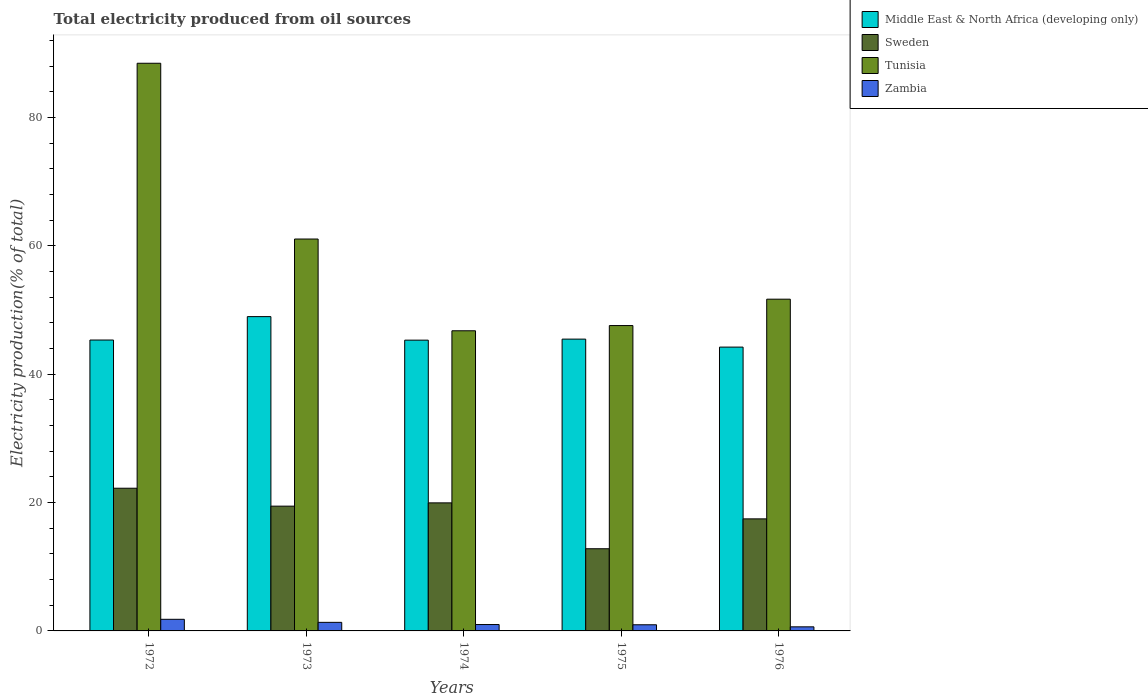How many bars are there on the 2nd tick from the left?
Your answer should be compact. 4. What is the label of the 3rd group of bars from the left?
Give a very brief answer. 1974. What is the total electricity produced in Middle East & North Africa (developing only) in 1975?
Make the answer very short. 45.47. Across all years, what is the maximum total electricity produced in Sweden?
Offer a very short reply. 22.24. Across all years, what is the minimum total electricity produced in Sweden?
Keep it short and to the point. 12.81. In which year was the total electricity produced in Tunisia maximum?
Your answer should be compact. 1972. In which year was the total electricity produced in Middle East & North Africa (developing only) minimum?
Keep it short and to the point. 1976. What is the total total electricity produced in Zambia in the graph?
Ensure brevity in your answer.  5.74. What is the difference between the total electricity produced in Tunisia in 1972 and that in 1973?
Your answer should be very brief. 27.39. What is the difference between the total electricity produced in Middle East & North Africa (developing only) in 1976 and the total electricity produced in Tunisia in 1972?
Provide a succinct answer. -44.23. What is the average total electricity produced in Zambia per year?
Provide a short and direct response. 1.15. In the year 1973, what is the difference between the total electricity produced in Middle East & North Africa (developing only) and total electricity produced in Sweden?
Offer a very short reply. 29.53. What is the ratio of the total electricity produced in Zambia in 1974 to that in 1976?
Your response must be concise. 1.56. What is the difference between the highest and the second highest total electricity produced in Zambia?
Provide a succinct answer. 0.48. What is the difference between the highest and the lowest total electricity produced in Sweden?
Your answer should be very brief. 9.43. Is the sum of the total electricity produced in Zambia in 1973 and 1974 greater than the maximum total electricity produced in Tunisia across all years?
Make the answer very short. No. Is it the case that in every year, the sum of the total electricity produced in Middle East & North Africa (developing only) and total electricity produced in Tunisia is greater than the sum of total electricity produced in Sweden and total electricity produced in Zambia?
Offer a terse response. Yes. What does the 3rd bar from the left in 1973 represents?
Give a very brief answer. Tunisia. What does the 3rd bar from the right in 1973 represents?
Make the answer very short. Sweden. How many bars are there?
Offer a terse response. 20. Are all the bars in the graph horizontal?
Your answer should be very brief. No. How many years are there in the graph?
Offer a very short reply. 5. Does the graph contain any zero values?
Ensure brevity in your answer.  No. How are the legend labels stacked?
Provide a short and direct response. Vertical. What is the title of the graph?
Offer a terse response. Total electricity produced from oil sources. What is the label or title of the Y-axis?
Make the answer very short. Electricity production(% of total). What is the Electricity production(% of total) in Middle East & North Africa (developing only) in 1972?
Make the answer very short. 45.33. What is the Electricity production(% of total) in Sweden in 1972?
Ensure brevity in your answer.  22.24. What is the Electricity production(% of total) in Tunisia in 1972?
Ensure brevity in your answer.  88.46. What is the Electricity production(% of total) in Zambia in 1972?
Your answer should be very brief. 1.81. What is the Electricity production(% of total) of Middle East & North Africa (developing only) in 1973?
Offer a terse response. 48.98. What is the Electricity production(% of total) in Sweden in 1973?
Provide a succinct answer. 19.44. What is the Electricity production(% of total) of Tunisia in 1973?
Make the answer very short. 61.07. What is the Electricity production(% of total) in Zambia in 1973?
Your response must be concise. 1.34. What is the Electricity production(% of total) of Middle East & North Africa (developing only) in 1974?
Make the answer very short. 45.31. What is the Electricity production(% of total) in Sweden in 1974?
Your response must be concise. 19.95. What is the Electricity production(% of total) of Tunisia in 1974?
Provide a succinct answer. 46.77. What is the Electricity production(% of total) in Zambia in 1974?
Keep it short and to the point. 0.99. What is the Electricity production(% of total) in Middle East & North Africa (developing only) in 1975?
Your response must be concise. 45.47. What is the Electricity production(% of total) of Sweden in 1975?
Your response must be concise. 12.81. What is the Electricity production(% of total) of Tunisia in 1975?
Your answer should be very brief. 47.59. What is the Electricity production(% of total) in Zambia in 1975?
Provide a succinct answer. 0.96. What is the Electricity production(% of total) in Middle East & North Africa (developing only) in 1976?
Your response must be concise. 44.23. What is the Electricity production(% of total) in Sweden in 1976?
Your answer should be very brief. 17.46. What is the Electricity production(% of total) in Tunisia in 1976?
Keep it short and to the point. 51.69. What is the Electricity production(% of total) of Zambia in 1976?
Offer a very short reply. 0.64. Across all years, what is the maximum Electricity production(% of total) in Middle East & North Africa (developing only)?
Offer a very short reply. 48.98. Across all years, what is the maximum Electricity production(% of total) of Sweden?
Make the answer very short. 22.24. Across all years, what is the maximum Electricity production(% of total) of Tunisia?
Provide a short and direct response. 88.46. Across all years, what is the maximum Electricity production(% of total) in Zambia?
Your response must be concise. 1.81. Across all years, what is the minimum Electricity production(% of total) in Middle East & North Africa (developing only)?
Make the answer very short. 44.23. Across all years, what is the minimum Electricity production(% of total) of Sweden?
Your answer should be very brief. 12.81. Across all years, what is the minimum Electricity production(% of total) of Tunisia?
Give a very brief answer. 46.77. Across all years, what is the minimum Electricity production(% of total) of Zambia?
Keep it short and to the point. 0.64. What is the total Electricity production(% of total) in Middle East & North Africa (developing only) in the graph?
Your response must be concise. 229.31. What is the total Electricity production(% of total) in Sweden in the graph?
Make the answer very short. 91.9. What is the total Electricity production(% of total) of Tunisia in the graph?
Provide a succinct answer. 295.58. What is the total Electricity production(% of total) of Zambia in the graph?
Offer a terse response. 5.74. What is the difference between the Electricity production(% of total) in Middle East & North Africa (developing only) in 1972 and that in 1973?
Make the answer very short. -3.65. What is the difference between the Electricity production(% of total) in Sweden in 1972 and that in 1973?
Offer a terse response. 2.79. What is the difference between the Electricity production(% of total) of Tunisia in 1972 and that in 1973?
Your response must be concise. 27.39. What is the difference between the Electricity production(% of total) in Zambia in 1972 and that in 1973?
Provide a succinct answer. 0.48. What is the difference between the Electricity production(% of total) of Middle East & North Africa (developing only) in 1972 and that in 1974?
Keep it short and to the point. 0.02. What is the difference between the Electricity production(% of total) in Sweden in 1972 and that in 1974?
Make the answer very short. 2.28. What is the difference between the Electricity production(% of total) of Tunisia in 1972 and that in 1974?
Give a very brief answer. 41.69. What is the difference between the Electricity production(% of total) of Zambia in 1972 and that in 1974?
Give a very brief answer. 0.82. What is the difference between the Electricity production(% of total) in Middle East & North Africa (developing only) in 1972 and that in 1975?
Give a very brief answer. -0.14. What is the difference between the Electricity production(% of total) in Sweden in 1972 and that in 1975?
Make the answer very short. 9.43. What is the difference between the Electricity production(% of total) of Tunisia in 1972 and that in 1975?
Your answer should be compact. 40.87. What is the difference between the Electricity production(% of total) of Zambia in 1972 and that in 1975?
Offer a very short reply. 0.85. What is the difference between the Electricity production(% of total) of Middle East & North Africa (developing only) in 1972 and that in 1976?
Your answer should be compact. 1.1. What is the difference between the Electricity production(% of total) in Sweden in 1972 and that in 1976?
Ensure brevity in your answer.  4.77. What is the difference between the Electricity production(% of total) of Tunisia in 1972 and that in 1976?
Give a very brief answer. 36.76. What is the difference between the Electricity production(% of total) in Zambia in 1972 and that in 1976?
Make the answer very short. 1.18. What is the difference between the Electricity production(% of total) in Middle East & North Africa (developing only) in 1973 and that in 1974?
Your response must be concise. 3.67. What is the difference between the Electricity production(% of total) of Sweden in 1973 and that in 1974?
Provide a succinct answer. -0.51. What is the difference between the Electricity production(% of total) in Tunisia in 1973 and that in 1974?
Offer a terse response. 14.3. What is the difference between the Electricity production(% of total) of Zambia in 1973 and that in 1974?
Your answer should be compact. 0.34. What is the difference between the Electricity production(% of total) of Middle East & North Africa (developing only) in 1973 and that in 1975?
Your answer should be very brief. 3.51. What is the difference between the Electricity production(% of total) of Sweden in 1973 and that in 1975?
Your response must be concise. 6.64. What is the difference between the Electricity production(% of total) in Tunisia in 1973 and that in 1975?
Make the answer very short. 13.48. What is the difference between the Electricity production(% of total) in Zambia in 1973 and that in 1975?
Provide a short and direct response. 0.38. What is the difference between the Electricity production(% of total) in Middle East & North Africa (developing only) in 1973 and that in 1976?
Your response must be concise. 4.75. What is the difference between the Electricity production(% of total) of Sweden in 1973 and that in 1976?
Provide a succinct answer. 1.98. What is the difference between the Electricity production(% of total) in Tunisia in 1973 and that in 1976?
Keep it short and to the point. 9.37. What is the difference between the Electricity production(% of total) in Zambia in 1973 and that in 1976?
Keep it short and to the point. 0.7. What is the difference between the Electricity production(% of total) in Middle East & North Africa (developing only) in 1974 and that in 1975?
Ensure brevity in your answer.  -0.16. What is the difference between the Electricity production(% of total) of Sweden in 1974 and that in 1975?
Offer a very short reply. 7.15. What is the difference between the Electricity production(% of total) of Tunisia in 1974 and that in 1975?
Your answer should be compact. -0.81. What is the difference between the Electricity production(% of total) of Zambia in 1974 and that in 1975?
Your answer should be very brief. 0.04. What is the difference between the Electricity production(% of total) in Middle East & North Africa (developing only) in 1974 and that in 1976?
Provide a succinct answer. 1.08. What is the difference between the Electricity production(% of total) of Sweden in 1974 and that in 1976?
Offer a very short reply. 2.49. What is the difference between the Electricity production(% of total) in Tunisia in 1974 and that in 1976?
Your answer should be very brief. -4.92. What is the difference between the Electricity production(% of total) of Zambia in 1974 and that in 1976?
Provide a short and direct response. 0.36. What is the difference between the Electricity production(% of total) in Middle East & North Africa (developing only) in 1975 and that in 1976?
Your response must be concise. 1.25. What is the difference between the Electricity production(% of total) of Sweden in 1975 and that in 1976?
Offer a terse response. -4.66. What is the difference between the Electricity production(% of total) of Tunisia in 1975 and that in 1976?
Make the answer very short. -4.11. What is the difference between the Electricity production(% of total) of Zambia in 1975 and that in 1976?
Your response must be concise. 0.32. What is the difference between the Electricity production(% of total) in Middle East & North Africa (developing only) in 1972 and the Electricity production(% of total) in Sweden in 1973?
Provide a short and direct response. 25.89. What is the difference between the Electricity production(% of total) in Middle East & North Africa (developing only) in 1972 and the Electricity production(% of total) in Tunisia in 1973?
Your answer should be compact. -15.74. What is the difference between the Electricity production(% of total) in Middle East & North Africa (developing only) in 1972 and the Electricity production(% of total) in Zambia in 1973?
Offer a very short reply. 43.99. What is the difference between the Electricity production(% of total) in Sweden in 1972 and the Electricity production(% of total) in Tunisia in 1973?
Your answer should be very brief. -38.83. What is the difference between the Electricity production(% of total) of Sweden in 1972 and the Electricity production(% of total) of Zambia in 1973?
Offer a terse response. 20.9. What is the difference between the Electricity production(% of total) of Tunisia in 1972 and the Electricity production(% of total) of Zambia in 1973?
Offer a terse response. 87.12. What is the difference between the Electricity production(% of total) in Middle East & North Africa (developing only) in 1972 and the Electricity production(% of total) in Sweden in 1974?
Your response must be concise. 25.38. What is the difference between the Electricity production(% of total) in Middle East & North Africa (developing only) in 1972 and the Electricity production(% of total) in Tunisia in 1974?
Give a very brief answer. -1.44. What is the difference between the Electricity production(% of total) in Middle East & North Africa (developing only) in 1972 and the Electricity production(% of total) in Zambia in 1974?
Your answer should be very brief. 44.34. What is the difference between the Electricity production(% of total) of Sweden in 1972 and the Electricity production(% of total) of Tunisia in 1974?
Provide a short and direct response. -24.54. What is the difference between the Electricity production(% of total) in Sweden in 1972 and the Electricity production(% of total) in Zambia in 1974?
Your response must be concise. 21.24. What is the difference between the Electricity production(% of total) in Tunisia in 1972 and the Electricity production(% of total) in Zambia in 1974?
Provide a succinct answer. 87.46. What is the difference between the Electricity production(% of total) in Middle East & North Africa (developing only) in 1972 and the Electricity production(% of total) in Sweden in 1975?
Provide a succinct answer. 32.52. What is the difference between the Electricity production(% of total) in Middle East & North Africa (developing only) in 1972 and the Electricity production(% of total) in Tunisia in 1975?
Keep it short and to the point. -2.26. What is the difference between the Electricity production(% of total) of Middle East & North Africa (developing only) in 1972 and the Electricity production(% of total) of Zambia in 1975?
Ensure brevity in your answer.  44.37. What is the difference between the Electricity production(% of total) in Sweden in 1972 and the Electricity production(% of total) in Tunisia in 1975?
Your answer should be very brief. -25.35. What is the difference between the Electricity production(% of total) of Sweden in 1972 and the Electricity production(% of total) of Zambia in 1975?
Your answer should be compact. 21.28. What is the difference between the Electricity production(% of total) in Tunisia in 1972 and the Electricity production(% of total) in Zambia in 1975?
Keep it short and to the point. 87.5. What is the difference between the Electricity production(% of total) of Middle East & North Africa (developing only) in 1972 and the Electricity production(% of total) of Sweden in 1976?
Make the answer very short. 27.87. What is the difference between the Electricity production(% of total) of Middle East & North Africa (developing only) in 1972 and the Electricity production(% of total) of Tunisia in 1976?
Your answer should be compact. -6.36. What is the difference between the Electricity production(% of total) in Middle East & North Africa (developing only) in 1972 and the Electricity production(% of total) in Zambia in 1976?
Keep it short and to the point. 44.69. What is the difference between the Electricity production(% of total) of Sweden in 1972 and the Electricity production(% of total) of Tunisia in 1976?
Ensure brevity in your answer.  -29.46. What is the difference between the Electricity production(% of total) in Sweden in 1972 and the Electricity production(% of total) in Zambia in 1976?
Ensure brevity in your answer.  21.6. What is the difference between the Electricity production(% of total) in Tunisia in 1972 and the Electricity production(% of total) in Zambia in 1976?
Make the answer very short. 87.82. What is the difference between the Electricity production(% of total) in Middle East & North Africa (developing only) in 1973 and the Electricity production(% of total) in Sweden in 1974?
Make the answer very short. 29.02. What is the difference between the Electricity production(% of total) of Middle East & North Africa (developing only) in 1973 and the Electricity production(% of total) of Tunisia in 1974?
Your answer should be compact. 2.21. What is the difference between the Electricity production(% of total) in Middle East & North Africa (developing only) in 1973 and the Electricity production(% of total) in Zambia in 1974?
Provide a succinct answer. 47.98. What is the difference between the Electricity production(% of total) in Sweden in 1973 and the Electricity production(% of total) in Tunisia in 1974?
Provide a succinct answer. -27.33. What is the difference between the Electricity production(% of total) of Sweden in 1973 and the Electricity production(% of total) of Zambia in 1974?
Keep it short and to the point. 18.45. What is the difference between the Electricity production(% of total) of Tunisia in 1973 and the Electricity production(% of total) of Zambia in 1974?
Offer a terse response. 60.07. What is the difference between the Electricity production(% of total) of Middle East & North Africa (developing only) in 1973 and the Electricity production(% of total) of Sweden in 1975?
Ensure brevity in your answer.  36.17. What is the difference between the Electricity production(% of total) in Middle East & North Africa (developing only) in 1973 and the Electricity production(% of total) in Tunisia in 1975?
Your answer should be compact. 1.39. What is the difference between the Electricity production(% of total) of Middle East & North Africa (developing only) in 1973 and the Electricity production(% of total) of Zambia in 1975?
Offer a terse response. 48.02. What is the difference between the Electricity production(% of total) in Sweden in 1973 and the Electricity production(% of total) in Tunisia in 1975?
Ensure brevity in your answer.  -28.14. What is the difference between the Electricity production(% of total) of Sweden in 1973 and the Electricity production(% of total) of Zambia in 1975?
Provide a succinct answer. 18.48. What is the difference between the Electricity production(% of total) in Tunisia in 1973 and the Electricity production(% of total) in Zambia in 1975?
Ensure brevity in your answer.  60.11. What is the difference between the Electricity production(% of total) in Middle East & North Africa (developing only) in 1973 and the Electricity production(% of total) in Sweden in 1976?
Provide a succinct answer. 31.52. What is the difference between the Electricity production(% of total) in Middle East & North Africa (developing only) in 1973 and the Electricity production(% of total) in Tunisia in 1976?
Ensure brevity in your answer.  -2.72. What is the difference between the Electricity production(% of total) of Middle East & North Africa (developing only) in 1973 and the Electricity production(% of total) of Zambia in 1976?
Your answer should be compact. 48.34. What is the difference between the Electricity production(% of total) in Sweden in 1973 and the Electricity production(% of total) in Tunisia in 1976?
Offer a very short reply. -32.25. What is the difference between the Electricity production(% of total) in Sweden in 1973 and the Electricity production(% of total) in Zambia in 1976?
Your answer should be very brief. 18.81. What is the difference between the Electricity production(% of total) of Tunisia in 1973 and the Electricity production(% of total) of Zambia in 1976?
Give a very brief answer. 60.43. What is the difference between the Electricity production(% of total) in Middle East & North Africa (developing only) in 1974 and the Electricity production(% of total) in Sweden in 1975?
Offer a terse response. 32.5. What is the difference between the Electricity production(% of total) of Middle East & North Africa (developing only) in 1974 and the Electricity production(% of total) of Tunisia in 1975?
Your answer should be compact. -2.28. What is the difference between the Electricity production(% of total) in Middle East & North Africa (developing only) in 1974 and the Electricity production(% of total) in Zambia in 1975?
Give a very brief answer. 44.35. What is the difference between the Electricity production(% of total) of Sweden in 1974 and the Electricity production(% of total) of Tunisia in 1975?
Your answer should be compact. -27.63. What is the difference between the Electricity production(% of total) of Sweden in 1974 and the Electricity production(% of total) of Zambia in 1975?
Offer a terse response. 18.99. What is the difference between the Electricity production(% of total) of Tunisia in 1974 and the Electricity production(% of total) of Zambia in 1975?
Ensure brevity in your answer.  45.81. What is the difference between the Electricity production(% of total) of Middle East & North Africa (developing only) in 1974 and the Electricity production(% of total) of Sweden in 1976?
Offer a terse response. 27.85. What is the difference between the Electricity production(% of total) of Middle East & North Africa (developing only) in 1974 and the Electricity production(% of total) of Tunisia in 1976?
Give a very brief answer. -6.38. What is the difference between the Electricity production(% of total) in Middle East & North Africa (developing only) in 1974 and the Electricity production(% of total) in Zambia in 1976?
Keep it short and to the point. 44.67. What is the difference between the Electricity production(% of total) of Sweden in 1974 and the Electricity production(% of total) of Tunisia in 1976?
Make the answer very short. -31.74. What is the difference between the Electricity production(% of total) in Sweden in 1974 and the Electricity production(% of total) in Zambia in 1976?
Offer a very short reply. 19.32. What is the difference between the Electricity production(% of total) in Tunisia in 1974 and the Electricity production(% of total) in Zambia in 1976?
Keep it short and to the point. 46.14. What is the difference between the Electricity production(% of total) of Middle East & North Africa (developing only) in 1975 and the Electricity production(% of total) of Sweden in 1976?
Your answer should be very brief. 28.01. What is the difference between the Electricity production(% of total) in Middle East & North Africa (developing only) in 1975 and the Electricity production(% of total) in Tunisia in 1976?
Your response must be concise. -6.22. What is the difference between the Electricity production(% of total) of Middle East & North Africa (developing only) in 1975 and the Electricity production(% of total) of Zambia in 1976?
Provide a short and direct response. 44.84. What is the difference between the Electricity production(% of total) of Sweden in 1975 and the Electricity production(% of total) of Tunisia in 1976?
Provide a short and direct response. -38.89. What is the difference between the Electricity production(% of total) in Sweden in 1975 and the Electricity production(% of total) in Zambia in 1976?
Your answer should be very brief. 12.17. What is the difference between the Electricity production(% of total) in Tunisia in 1975 and the Electricity production(% of total) in Zambia in 1976?
Offer a very short reply. 46.95. What is the average Electricity production(% of total) of Middle East & North Africa (developing only) per year?
Make the answer very short. 45.86. What is the average Electricity production(% of total) in Sweden per year?
Keep it short and to the point. 18.38. What is the average Electricity production(% of total) in Tunisia per year?
Your response must be concise. 59.12. What is the average Electricity production(% of total) in Zambia per year?
Your answer should be very brief. 1.15. In the year 1972, what is the difference between the Electricity production(% of total) in Middle East & North Africa (developing only) and Electricity production(% of total) in Sweden?
Make the answer very short. 23.09. In the year 1972, what is the difference between the Electricity production(% of total) of Middle East & North Africa (developing only) and Electricity production(% of total) of Tunisia?
Provide a short and direct response. -43.13. In the year 1972, what is the difference between the Electricity production(% of total) in Middle East & North Africa (developing only) and Electricity production(% of total) in Zambia?
Your answer should be very brief. 43.52. In the year 1972, what is the difference between the Electricity production(% of total) in Sweden and Electricity production(% of total) in Tunisia?
Provide a succinct answer. -66.22. In the year 1972, what is the difference between the Electricity production(% of total) in Sweden and Electricity production(% of total) in Zambia?
Ensure brevity in your answer.  20.43. In the year 1972, what is the difference between the Electricity production(% of total) in Tunisia and Electricity production(% of total) in Zambia?
Provide a short and direct response. 86.65. In the year 1973, what is the difference between the Electricity production(% of total) of Middle East & North Africa (developing only) and Electricity production(% of total) of Sweden?
Your answer should be compact. 29.53. In the year 1973, what is the difference between the Electricity production(% of total) in Middle East & North Africa (developing only) and Electricity production(% of total) in Tunisia?
Make the answer very short. -12.09. In the year 1973, what is the difference between the Electricity production(% of total) in Middle East & North Africa (developing only) and Electricity production(% of total) in Zambia?
Offer a terse response. 47.64. In the year 1973, what is the difference between the Electricity production(% of total) in Sweden and Electricity production(% of total) in Tunisia?
Ensure brevity in your answer.  -41.63. In the year 1973, what is the difference between the Electricity production(% of total) of Sweden and Electricity production(% of total) of Zambia?
Give a very brief answer. 18.11. In the year 1973, what is the difference between the Electricity production(% of total) in Tunisia and Electricity production(% of total) in Zambia?
Make the answer very short. 59.73. In the year 1974, what is the difference between the Electricity production(% of total) in Middle East & North Africa (developing only) and Electricity production(% of total) in Sweden?
Provide a short and direct response. 25.36. In the year 1974, what is the difference between the Electricity production(% of total) of Middle East & North Africa (developing only) and Electricity production(% of total) of Tunisia?
Provide a succinct answer. -1.46. In the year 1974, what is the difference between the Electricity production(% of total) of Middle East & North Africa (developing only) and Electricity production(% of total) of Zambia?
Ensure brevity in your answer.  44.32. In the year 1974, what is the difference between the Electricity production(% of total) of Sweden and Electricity production(% of total) of Tunisia?
Give a very brief answer. -26.82. In the year 1974, what is the difference between the Electricity production(% of total) of Sweden and Electricity production(% of total) of Zambia?
Give a very brief answer. 18.96. In the year 1974, what is the difference between the Electricity production(% of total) of Tunisia and Electricity production(% of total) of Zambia?
Keep it short and to the point. 45.78. In the year 1975, what is the difference between the Electricity production(% of total) of Middle East & North Africa (developing only) and Electricity production(% of total) of Sweden?
Offer a very short reply. 32.67. In the year 1975, what is the difference between the Electricity production(% of total) of Middle East & North Africa (developing only) and Electricity production(% of total) of Tunisia?
Your response must be concise. -2.11. In the year 1975, what is the difference between the Electricity production(% of total) in Middle East & North Africa (developing only) and Electricity production(% of total) in Zambia?
Your answer should be compact. 44.51. In the year 1975, what is the difference between the Electricity production(% of total) of Sweden and Electricity production(% of total) of Tunisia?
Your answer should be compact. -34.78. In the year 1975, what is the difference between the Electricity production(% of total) in Sweden and Electricity production(% of total) in Zambia?
Offer a very short reply. 11.85. In the year 1975, what is the difference between the Electricity production(% of total) in Tunisia and Electricity production(% of total) in Zambia?
Your answer should be compact. 46.63. In the year 1976, what is the difference between the Electricity production(% of total) of Middle East & North Africa (developing only) and Electricity production(% of total) of Sweden?
Provide a short and direct response. 26.76. In the year 1976, what is the difference between the Electricity production(% of total) in Middle East & North Africa (developing only) and Electricity production(% of total) in Tunisia?
Provide a short and direct response. -7.47. In the year 1976, what is the difference between the Electricity production(% of total) of Middle East & North Africa (developing only) and Electricity production(% of total) of Zambia?
Make the answer very short. 43.59. In the year 1976, what is the difference between the Electricity production(% of total) of Sweden and Electricity production(% of total) of Tunisia?
Your response must be concise. -34.23. In the year 1976, what is the difference between the Electricity production(% of total) of Sweden and Electricity production(% of total) of Zambia?
Your answer should be very brief. 16.83. In the year 1976, what is the difference between the Electricity production(% of total) of Tunisia and Electricity production(% of total) of Zambia?
Offer a very short reply. 51.06. What is the ratio of the Electricity production(% of total) of Middle East & North Africa (developing only) in 1972 to that in 1973?
Your answer should be very brief. 0.93. What is the ratio of the Electricity production(% of total) in Sweden in 1972 to that in 1973?
Provide a succinct answer. 1.14. What is the ratio of the Electricity production(% of total) of Tunisia in 1972 to that in 1973?
Offer a terse response. 1.45. What is the ratio of the Electricity production(% of total) of Zambia in 1972 to that in 1973?
Your answer should be very brief. 1.36. What is the ratio of the Electricity production(% of total) in Middle East & North Africa (developing only) in 1972 to that in 1974?
Keep it short and to the point. 1. What is the ratio of the Electricity production(% of total) of Sweden in 1972 to that in 1974?
Keep it short and to the point. 1.11. What is the ratio of the Electricity production(% of total) in Tunisia in 1972 to that in 1974?
Provide a succinct answer. 1.89. What is the ratio of the Electricity production(% of total) in Zambia in 1972 to that in 1974?
Offer a terse response. 1.82. What is the ratio of the Electricity production(% of total) in Sweden in 1972 to that in 1975?
Your answer should be compact. 1.74. What is the ratio of the Electricity production(% of total) in Tunisia in 1972 to that in 1975?
Your answer should be compact. 1.86. What is the ratio of the Electricity production(% of total) in Zambia in 1972 to that in 1975?
Offer a terse response. 1.89. What is the ratio of the Electricity production(% of total) of Middle East & North Africa (developing only) in 1972 to that in 1976?
Offer a terse response. 1.02. What is the ratio of the Electricity production(% of total) of Sweden in 1972 to that in 1976?
Give a very brief answer. 1.27. What is the ratio of the Electricity production(% of total) in Tunisia in 1972 to that in 1976?
Keep it short and to the point. 1.71. What is the ratio of the Electricity production(% of total) in Zambia in 1972 to that in 1976?
Provide a succinct answer. 2.85. What is the ratio of the Electricity production(% of total) in Middle East & North Africa (developing only) in 1973 to that in 1974?
Ensure brevity in your answer.  1.08. What is the ratio of the Electricity production(% of total) in Sweden in 1973 to that in 1974?
Provide a short and direct response. 0.97. What is the ratio of the Electricity production(% of total) in Tunisia in 1973 to that in 1974?
Keep it short and to the point. 1.31. What is the ratio of the Electricity production(% of total) of Zambia in 1973 to that in 1974?
Ensure brevity in your answer.  1.34. What is the ratio of the Electricity production(% of total) of Middle East & North Africa (developing only) in 1973 to that in 1975?
Provide a short and direct response. 1.08. What is the ratio of the Electricity production(% of total) of Sweden in 1973 to that in 1975?
Give a very brief answer. 1.52. What is the ratio of the Electricity production(% of total) in Tunisia in 1973 to that in 1975?
Make the answer very short. 1.28. What is the ratio of the Electricity production(% of total) of Zambia in 1973 to that in 1975?
Keep it short and to the point. 1.39. What is the ratio of the Electricity production(% of total) in Middle East & North Africa (developing only) in 1973 to that in 1976?
Give a very brief answer. 1.11. What is the ratio of the Electricity production(% of total) in Sweden in 1973 to that in 1976?
Ensure brevity in your answer.  1.11. What is the ratio of the Electricity production(% of total) of Tunisia in 1973 to that in 1976?
Provide a succinct answer. 1.18. What is the ratio of the Electricity production(% of total) in Zambia in 1973 to that in 1976?
Your answer should be compact. 2.1. What is the ratio of the Electricity production(% of total) in Sweden in 1974 to that in 1975?
Make the answer very short. 1.56. What is the ratio of the Electricity production(% of total) in Tunisia in 1974 to that in 1975?
Keep it short and to the point. 0.98. What is the ratio of the Electricity production(% of total) in Zambia in 1974 to that in 1975?
Ensure brevity in your answer.  1.04. What is the ratio of the Electricity production(% of total) in Middle East & North Africa (developing only) in 1974 to that in 1976?
Provide a succinct answer. 1.02. What is the ratio of the Electricity production(% of total) of Sweden in 1974 to that in 1976?
Offer a very short reply. 1.14. What is the ratio of the Electricity production(% of total) in Tunisia in 1974 to that in 1976?
Give a very brief answer. 0.9. What is the ratio of the Electricity production(% of total) of Zambia in 1974 to that in 1976?
Offer a terse response. 1.56. What is the ratio of the Electricity production(% of total) of Middle East & North Africa (developing only) in 1975 to that in 1976?
Give a very brief answer. 1.03. What is the ratio of the Electricity production(% of total) in Sweden in 1975 to that in 1976?
Your response must be concise. 0.73. What is the ratio of the Electricity production(% of total) in Tunisia in 1975 to that in 1976?
Make the answer very short. 0.92. What is the ratio of the Electricity production(% of total) of Zambia in 1975 to that in 1976?
Your answer should be very brief. 1.51. What is the difference between the highest and the second highest Electricity production(% of total) in Middle East & North Africa (developing only)?
Make the answer very short. 3.51. What is the difference between the highest and the second highest Electricity production(% of total) in Sweden?
Offer a terse response. 2.28. What is the difference between the highest and the second highest Electricity production(% of total) of Tunisia?
Your answer should be compact. 27.39. What is the difference between the highest and the second highest Electricity production(% of total) of Zambia?
Your response must be concise. 0.48. What is the difference between the highest and the lowest Electricity production(% of total) in Middle East & North Africa (developing only)?
Keep it short and to the point. 4.75. What is the difference between the highest and the lowest Electricity production(% of total) in Sweden?
Provide a short and direct response. 9.43. What is the difference between the highest and the lowest Electricity production(% of total) in Tunisia?
Ensure brevity in your answer.  41.69. What is the difference between the highest and the lowest Electricity production(% of total) in Zambia?
Give a very brief answer. 1.18. 